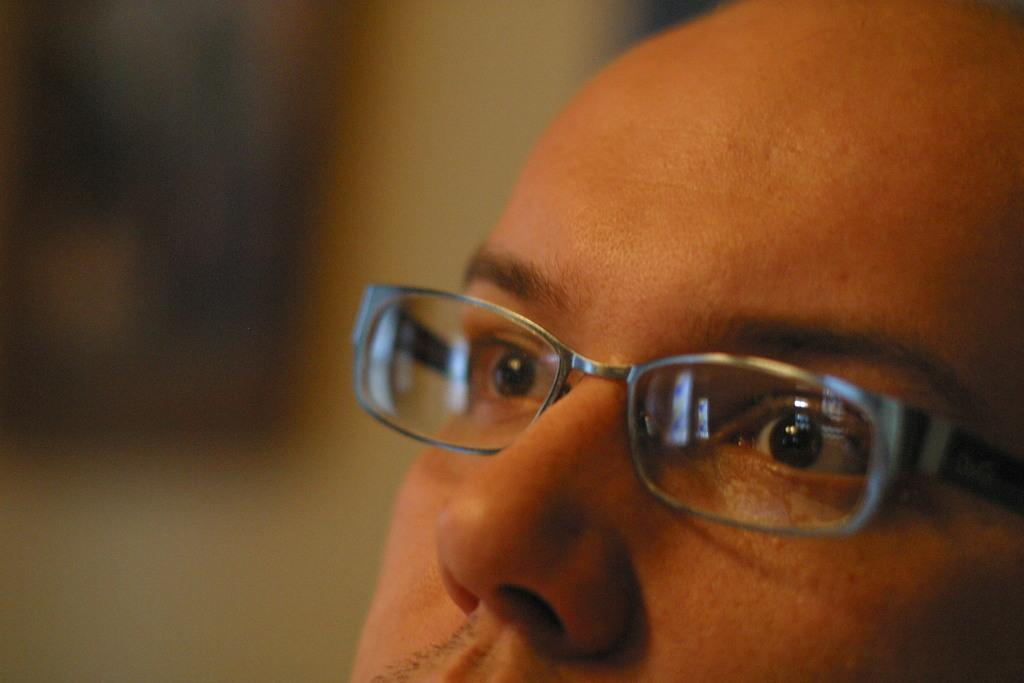Who is the main subject in the image? There is a man in the image. What is the man wearing in the image? The man is wearing spectacles in the image. Can you describe the background of the image? The background of the image is blurred. What type of credit card does the man have in the image? There is no credit card visible in the image. What kind of suit is the man wearing in the image? The man is not wearing a suit in the image; he is wearing spectacles. 